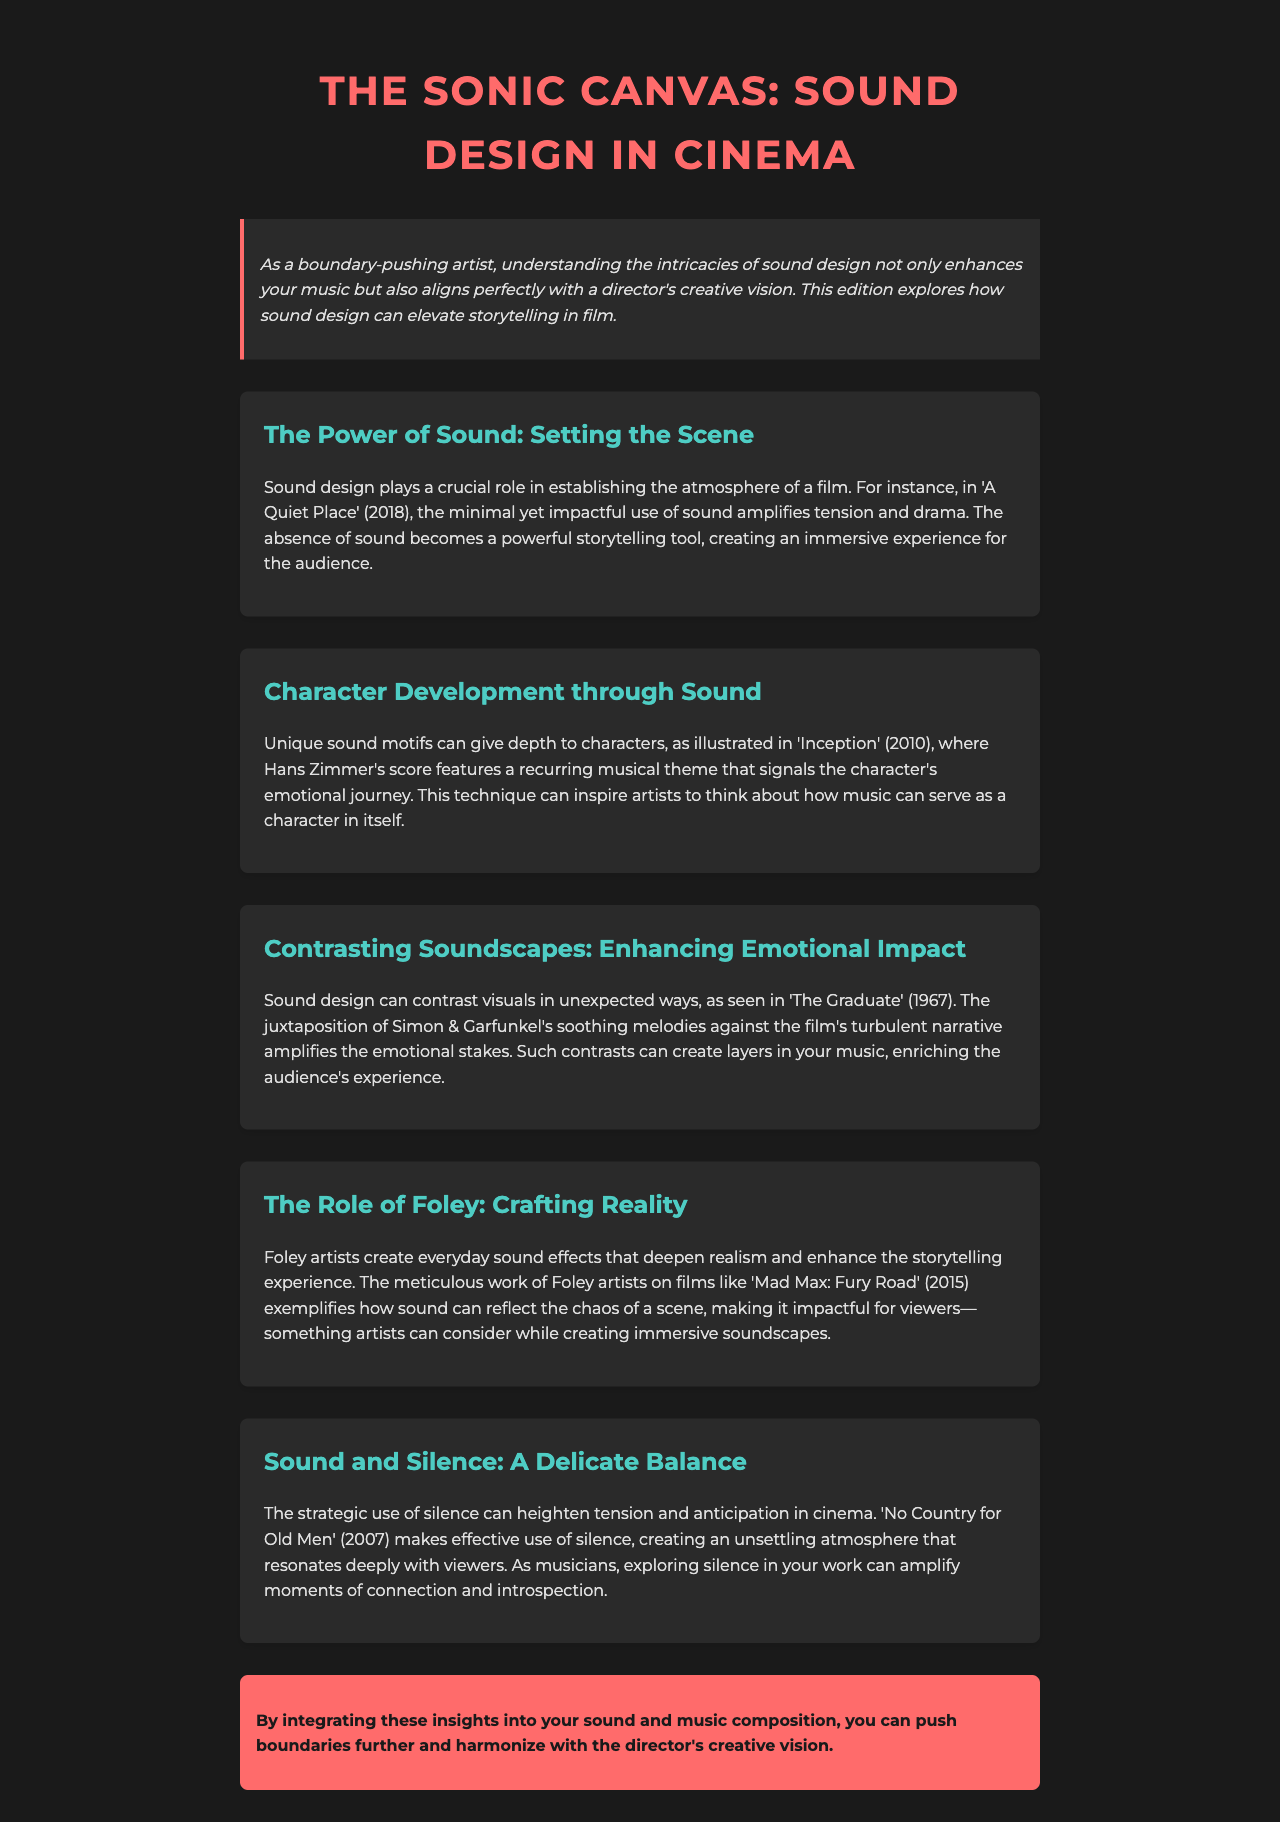What film is used as an example for the power of sound? The document mentions 'A Quiet Place' to illustrate the impact of sound design in establishing atmosphere.
Answer: 'A Quiet Place' What year was 'Inception' released? The document refers to 'Inception' as being released in 2010, demonstrating unique sound motifs for character development.
Answer: 2010 Which technique can give depth to characters according to the document? Unique sound motifs are noted as a technique that provides depth to characters, like in 'Inception'.
Answer: Unique sound motifs What contrasting element is highlighted in 'The Graduate'? The document discusses the juxtaposition of soothing melodies against a turbulent narrative in 'The Graduate'.
Answer: Soothing melodies Which film exemplifies the role of Foley artists? 'Mad Max: Fury Road' is cited as a film that showcases the contributions of Foley artists in creating sound effects.
Answer: 'Mad Max: Fury Road' What does the document suggest exploring in music to amplify moments? It emphasizes exploring silence in music to heighten connection and introspection, referencing 'No Country for Old Men'.
Answer: Silence How does the document describe the overall purpose of integrating sound insights? The document concludes that integrating these insights into sound composition harmonizes with the director's creative vision.
Answer: Harmonize with the director's creative vision What is the title of the newsletter? The title of the newsletter is "The Sonic Canvas: Sound Design in Cinema".
Answer: The Sonic Canvas: Sound Design in Cinema 